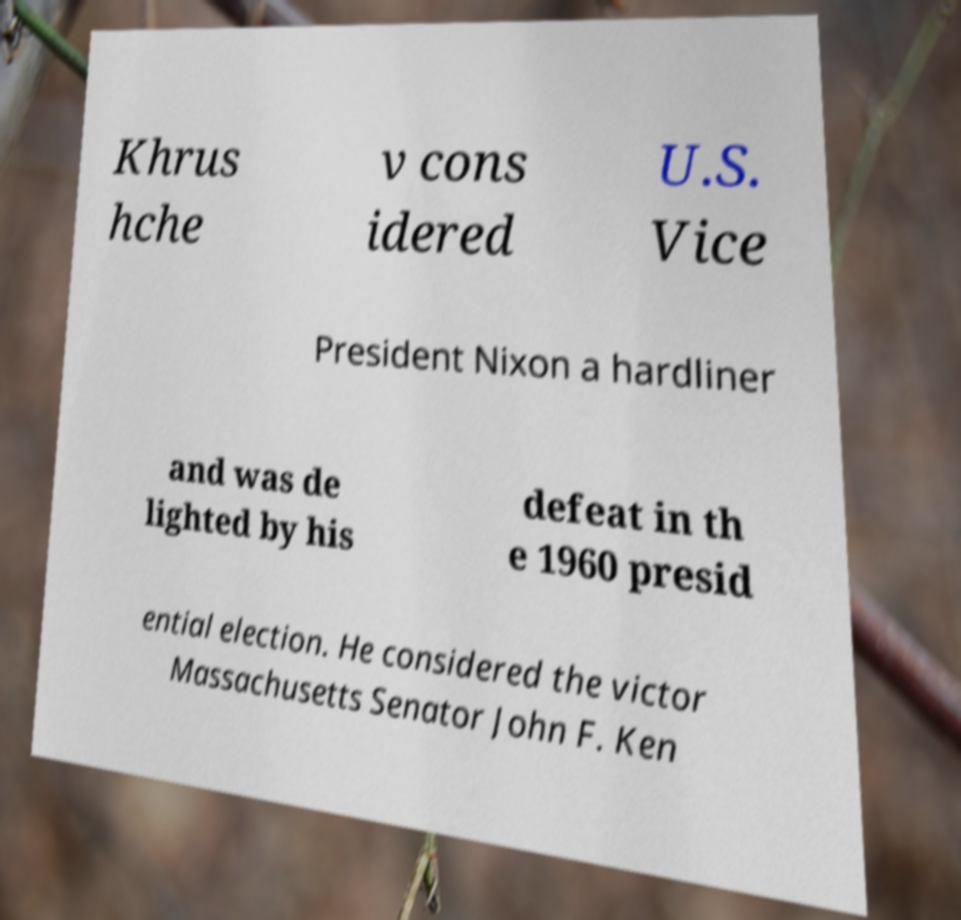Please identify and transcribe the text found in this image. Khrus hche v cons idered U.S. Vice President Nixon a hardliner and was de lighted by his defeat in th e 1960 presid ential election. He considered the victor Massachusetts Senator John F. Ken 